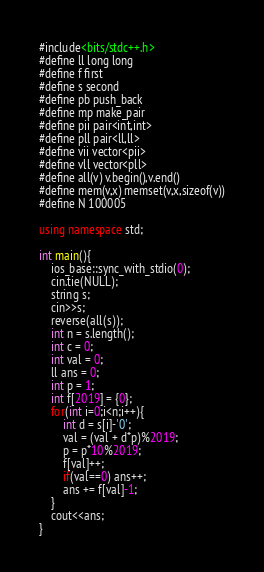<code> <loc_0><loc_0><loc_500><loc_500><_C++_>#include<bits/stdc++.h>
#define ll long long
#define f first
#define s second
#define pb push_back
#define mp make_pair
#define pii pair<int,int>
#define pll pair<ll,ll>
#define vii vector<pii>
#define vll vector<pll>
#define all(v) v.begin(),v.end()
#define mem(v,x) memset(v,x,sizeof(v))
#define N 100005

using namespace std;

int main(){
    ios_base::sync_with_stdio(0);
	cin.tie(NULL);
    string s;
    cin>>s;
    reverse(all(s));
    int n = s.length();
    int c = 0;
    int val = 0;
    ll ans = 0;
    int p = 1;
    int f[2019] = {0};
    for(int i=0;i<n;i++){
        int d = s[i]-'0';
        val = (val + d*p)%2019;
        p = p*10%2019;
        f[val]++;
        if(val==0) ans++;
        ans += f[val]-1;
    }
    cout<<ans;
}
</code> 